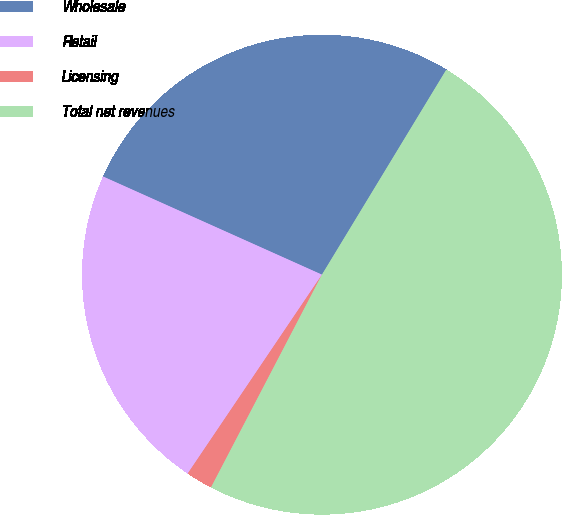<chart> <loc_0><loc_0><loc_500><loc_500><pie_chart><fcel>Wholesale<fcel>Retail<fcel>Licensing<fcel>Total net revenues<nl><fcel>26.97%<fcel>22.26%<fcel>1.8%<fcel>48.97%<nl></chart> 